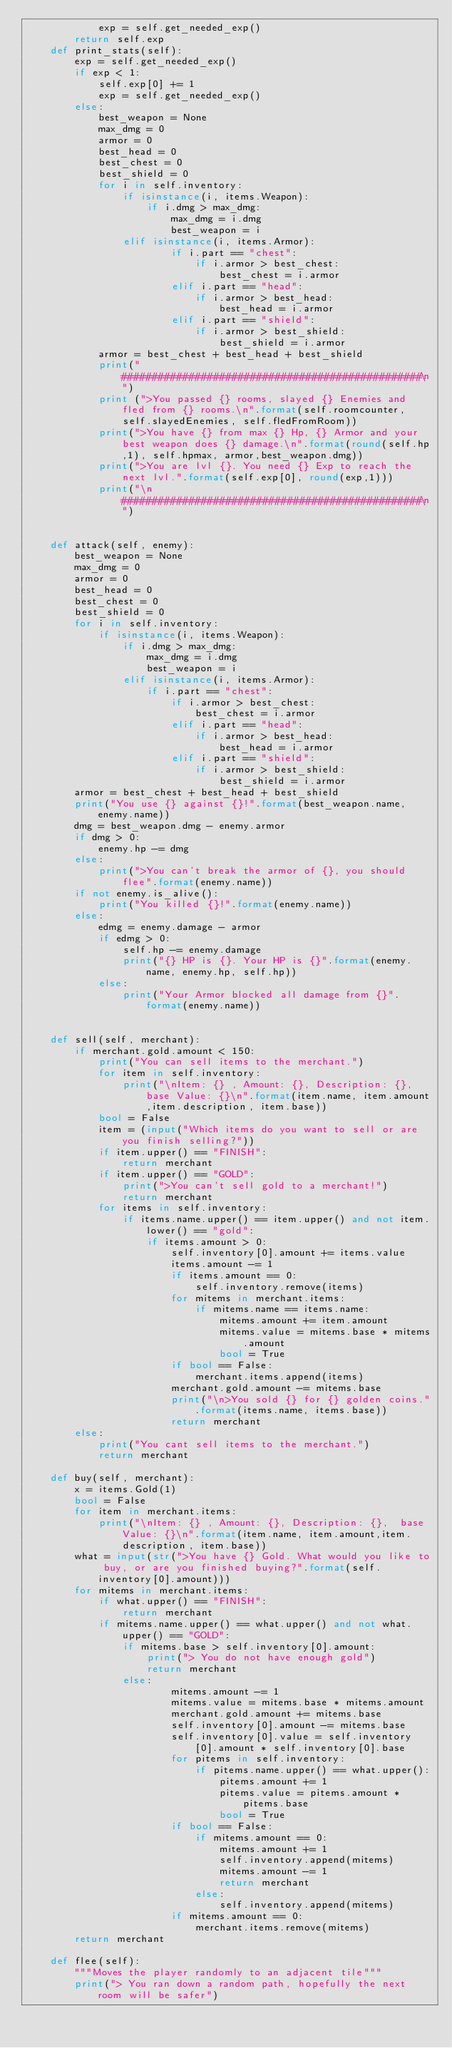<code> <loc_0><loc_0><loc_500><loc_500><_Python_>            exp = self.get_needed_exp()
        return self.exp
    def print_stats(self):
        exp = self.get_needed_exp()
        if exp < 1:
            self.exp[0] += 1
            exp = self.get_needed_exp()
        else:
            best_weapon = None
            max_dmg = 0
            armor = 0
            best_head = 0
            best_chest = 0
            best_shield = 0
            for i in self.inventory:
                if isinstance(i, items.Weapon):
                    if i.dmg > max_dmg:
                        max_dmg = i.dmg
                        best_weapon = i
                elif isinstance(i, items.Armor):
                        if i.part == "chest":
                            if i.armor > best_chest:
                                best_chest = i.armor
                        elif i.part == "head":
                            if i.armor > best_head:
                                best_head = i.armor
                        elif i.part == "shield":
                            if i.armor > best_shield:
                                best_shield = i.armor
            armor = best_chest + best_head + best_shield
            print("#################################################\n")
            print (">You passed {} rooms, slayed {} Enemies and fled from {} rooms.\n".format(self.roomcounter, self.slayedEnemies, self.fledFromRoom))
            print(">You have {} from max {} Hp, {} Armor and your best weapon does {} damage.\n".format(round(self.hp,1), self.hpmax, armor,best_weapon.dmg))
            print(">You are lvl {}. You need {} Exp to reach the next lvl.".format(self.exp[0], round(exp,1)))
            print("\n#################################################\n")


    def attack(self, enemy):
        best_weapon = None
        max_dmg = 0
        armor = 0
        best_head = 0
        best_chest = 0
        best_shield = 0
        for i in self.inventory:
            if isinstance(i, items.Weapon):
                if i.dmg > max_dmg:
                    max_dmg = i.dmg
                    best_weapon = i
                elif isinstance(i, items.Armor):
                    if i.part == "chest":
                        if i.armor > best_chest:
                            best_chest = i.armor
                        elif i.part == "head":
                            if i.armor > best_head:
                                best_head = i.armor
                        elif i.part == "shield":
                            if i.armor > best_shield:
                                best_shield = i.armor
        armor = best_chest + best_head + best_shield
        print("You use {} against {}!".format(best_weapon.name, enemy.name))
        dmg = best_weapon.dmg - enemy.armor
        if dmg > 0:
            enemy.hp -= dmg
        else:
            print(">You can't break the armor of {}, you should flee".format(enemy.name))
        if not enemy.is_alive():
            print("You killed {}!".format(enemy.name))
        else:
            edmg = enemy.damage - armor
            if edmg > 0:
                self.hp -= enemy.damage
                print("{} HP is {}. Your HP is {}".format(enemy.name, enemy.hp, self.hp))
            else:
                print("Your Armor blocked all damage from {}".format(enemy.name))


    def sell(self, merchant):
        if merchant.gold.amount < 150:
            print("You can sell items to the merchant.")
            for item in self.inventory:
                print("\nItem: {} , Amount: {}, Description: {},  base Value: {}\n".format(item.name, item.amount,item.description, item.base))
            bool = False
            item = (input("Which items do you want to sell or are you finish selling?"))
            if item.upper() == "FINISH":
                return merchant
            if item.upper() == "GOLD":
                print(">You can't sell gold to a merchant!")
                return merchant
            for items in self.inventory:
                if items.name.upper() == item.upper() and not item.lower() == "gold":
                    if items.amount > 0:
                        self.inventory[0].amount += items.value
                        items.amount -= 1
                        if items.amount == 0:
                            self.inventory.remove(items)
                        for mitems in merchant.items:
                            if mitems.name == items.name:
                                mitems.amount += item.amount
                                mitems.value = mitems.base * mitems.amount
                                bool = True
                        if bool == False:
                            merchant.items.append(items)
                        merchant.gold.amount -= mitems.base
                        print("\n>You sold {} for {} golden coins.".format(items.name, items.base))
                        return merchant
        else:
            print("You cant sell items to the merchant.")
            return merchant

    def buy(self, merchant):
        x = items.Gold(1)
        bool = False
        for item in merchant.items:
            print("\nItem: {} , Amount: {}, Description: {},  base Value: {}\n".format(item.name, item.amount,item.description, item.base))
        what = input(str(">You have {} Gold. What would you like to buy, or are you finished buying?".format(self.inventory[0].amount)))
        for mitems in merchant.items:
            if what.upper() == "FINISH":
                return merchant
            if mitems.name.upper() == what.upper() and not what.upper() == "GOLD":
                if mitems.base > self.inventory[0].amount:
                    print("> You do not have enough gold")
                    return merchant
                else:
                        mitems.amount -= 1
                        mitems.value = mitems.base * mitems.amount
                        merchant.gold.amount += mitems.base
                        self.inventory[0].amount -= mitems.base
                        self.inventory[0].value = self.inventory[0].amount * self.inventory[0].base
                        for pitems in self.inventory:
                            if pitems.name.upper() == what.upper():
                                pitems.amount += 1
                                pitems.value = pitems.amount * pitems.base
                                bool = True
                        if bool == False:
                            if mitems.amount == 0:
                                mitems.amount += 1
                                self.inventory.append(mitems)
                                mitems.amount -= 1
                                return merchant
                            else:
                                self.inventory.append(mitems)
                        if mitems.amount == 0:
                            merchant.items.remove(mitems)
        return merchant

    def flee(self):
        """Moves the player randomly to an adjacent tile"""
        print("> You ran down a random path, hopefully the next room will be safer")
</code> 